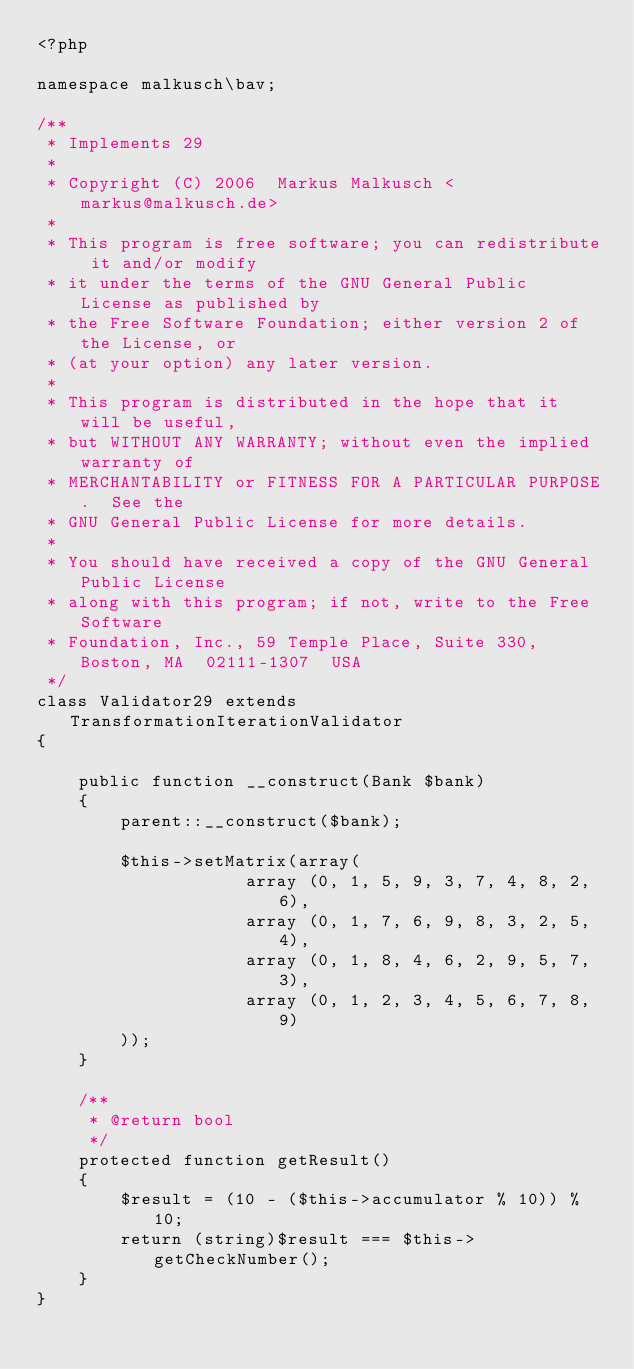Convert code to text. <code><loc_0><loc_0><loc_500><loc_500><_PHP_><?php

namespace malkusch\bav;

/**
 * Implements 29
 *
 * Copyright (C) 2006  Markus Malkusch <markus@malkusch.de>
 *
 * This program is free software; you can redistribute it and/or modify
 * it under the terms of the GNU General Public License as published by
 * the Free Software Foundation; either version 2 of the License, or
 * (at your option) any later version.
 *
 * This program is distributed in the hope that it will be useful,
 * but WITHOUT ANY WARRANTY; without even the implied warranty of
 * MERCHANTABILITY or FITNESS FOR A PARTICULAR PURPOSE.  See the
 * GNU General Public License for more details.
 *
 * You should have received a copy of the GNU General Public License
 * along with this program; if not, write to the Free Software
 * Foundation, Inc., 59 Temple Place, Suite 330, Boston, MA  02111-1307  USA
 */
class Validator29 extends TransformationIterationValidator
{

    public function __construct(Bank $bank)
    {
        parent::__construct($bank);

        $this->setMatrix(array(
                    array (0, 1, 5, 9, 3, 7, 4, 8, 2, 6),
                    array (0, 1, 7, 6, 9, 8, 3, 2, 5, 4),
                    array (0, 1, 8, 4, 6, 2, 9, 5, 7, 3),
                    array (0, 1, 2, 3, 4, 5, 6, 7, 8, 9)
        ));
    }

    /**
     * @return bool
     */
    protected function getResult()
    {
        $result = (10 - ($this->accumulator % 10)) % 10;
        return (string)$result === $this->getCheckNumber();
    }
}
</code> 